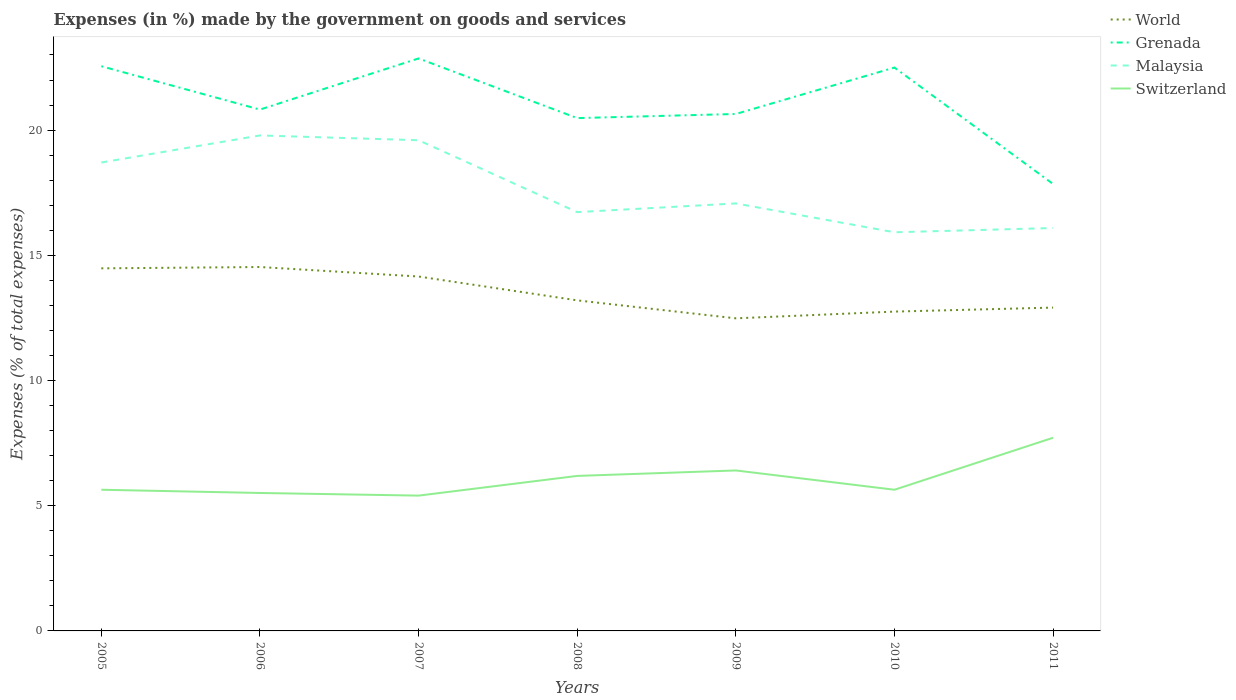Across all years, what is the maximum percentage of expenses made by the government on goods and services in Grenada?
Offer a terse response. 17.85. In which year was the percentage of expenses made by the government on goods and services in World maximum?
Make the answer very short. 2009. What is the total percentage of expenses made by the government on goods and services in Grenada in the graph?
Make the answer very short. 2.22. What is the difference between the highest and the second highest percentage of expenses made by the government on goods and services in Grenada?
Offer a very short reply. 5.01. How many years are there in the graph?
Your response must be concise. 7. What is the difference between two consecutive major ticks on the Y-axis?
Ensure brevity in your answer.  5. Does the graph contain any zero values?
Make the answer very short. No. Does the graph contain grids?
Make the answer very short. No. Where does the legend appear in the graph?
Give a very brief answer. Top right. How are the legend labels stacked?
Offer a terse response. Vertical. What is the title of the graph?
Provide a succinct answer. Expenses (in %) made by the government on goods and services. What is the label or title of the Y-axis?
Make the answer very short. Expenses (% of total expenses). What is the Expenses (% of total expenses) of World in 2005?
Provide a short and direct response. 14.48. What is the Expenses (% of total expenses) in Grenada in 2005?
Your response must be concise. 22.55. What is the Expenses (% of total expenses) in Malaysia in 2005?
Offer a very short reply. 18.71. What is the Expenses (% of total expenses) of Switzerland in 2005?
Give a very brief answer. 5.64. What is the Expenses (% of total expenses) of World in 2006?
Your answer should be very brief. 14.53. What is the Expenses (% of total expenses) in Grenada in 2006?
Provide a short and direct response. 20.82. What is the Expenses (% of total expenses) in Malaysia in 2006?
Provide a succinct answer. 19.79. What is the Expenses (% of total expenses) in Switzerland in 2006?
Provide a succinct answer. 5.51. What is the Expenses (% of total expenses) of World in 2007?
Offer a terse response. 14.15. What is the Expenses (% of total expenses) in Grenada in 2007?
Your answer should be compact. 22.86. What is the Expenses (% of total expenses) in Malaysia in 2007?
Your response must be concise. 19.6. What is the Expenses (% of total expenses) in Switzerland in 2007?
Offer a very short reply. 5.4. What is the Expenses (% of total expenses) in World in 2008?
Make the answer very short. 13.2. What is the Expenses (% of total expenses) of Grenada in 2008?
Provide a short and direct response. 20.48. What is the Expenses (% of total expenses) in Malaysia in 2008?
Your answer should be very brief. 16.72. What is the Expenses (% of total expenses) in Switzerland in 2008?
Make the answer very short. 6.19. What is the Expenses (% of total expenses) of World in 2009?
Ensure brevity in your answer.  12.48. What is the Expenses (% of total expenses) in Grenada in 2009?
Provide a succinct answer. 20.64. What is the Expenses (% of total expenses) in Malaysia in 2009?
Ensure brevity in your answer.  17.07. What is the Expenses (% of total expenses) of Switzerland in 2009?
Give a very brief answer. 6.41. What is the Expenses (% of total expenses) of World in 2010?
Offer a terse response. 12.75. What is the Expenses (% of total expenses) in Grenada in 2010?
Offer a very short reply. 22.5. What is the Expenses (% of total expenses) of Malaysia in 2010?
Keep it short and to the point. 15.92. What is the Expenses (% of total expenses) of Switzerland in 2010?
Give a very brief answer. 5.64. What is the Expenses (% of total expenses) of World in 2011?
Your answer should be very brief. 12.91. What is the Expenses (% of total expenses) in Grenada in 2011?
Your answer should be very brief. 17.85. What is the Expenses (% of total expenses) in Malaysia in 2011?
Ensure brevity in your answer.  16.09. What is the Expenses (% of total expenses) of Switzerland in 2011?
Give a very brief answer. 7.71. Across all years, what is the maximum Expenses (% of total expenses) of World?
Keep it short and to the point. 14.53. Across all years, what is the maximum Expenses (% of total expenses) of Grenada?
Provide a succinct answer. 22.86. Across all years, what is the maximum Expenses (% of total expenses) of Malaysia?
Offer a very short reply. 19.79. Across all years, what is the maximum Expenses (% of total expenses) of Switzerland?
Provide a succinct answer. 7.71. Across all years, what is the minimum Expenses (% of total expenses) in World?
Make the answer very short. 12.48. Across all years, what is the minimum Expenses (% of total expenses) of Grenada?
Give a very brief answer. 17.85. Across all years, what is the minimum Expenses (% of total expenses) of Malaysia?
Keep it short and to the point. 15.92. Across all years, what is the minimum Expenses (% of total expenses) of Switzerland?
Offer a terse response. 5.4. What is the total Expenses (% of total expenses) of World in the graph?
Offer a terse response. 94.51. What is the total Expenses (% of total expenses) of Grenada in the graph?
Provide a succinct answer. 147.7. What is the total Expenses (% of total expenses) of Malaysia in the graph?
Your response must be concise. 123.89. What is the total Expenses (% of total expenses) of Switzerland in the graph?
Make the answer very short. 42.5. What is the difference between the Expenses (% of total expenses) in World in 2005 and that in 2006?
Provide a succinct answer. -0.05. What is the difference between the Expenses (% of total expenses) of Grenada in 2005 and that in 2006?
Ensure brevity in your answer.  1.73. What is the difference between the Expenses (% of total expenses) of Malaysia in 2005 and that in 2006?
Make the answer very short. -1.08. What is the difference between the Expenses (% of total expenses) in Switzerland in 2005 and that in 2006?
Your answer should be very brief. 0.13. What is the difference between the Expenses (% of total expenses) of World in 2005 and that in 2007?
Offer a terse response. 0.33. What is the difference between the Expenses (% of total expenses) of Grenada in 2005 and that in 2007?
Give a very brief answer. -0.31. What is the difference between the Expenses (% of total expenses) in Malaysia in 2005 and that in 2007?
Provide a succinct answer. -0.89. What is the difference between the Expenses (% of total expenses) in Switzerland in 2005 and that in 2007?
Give a very brief answer. 0.23. What is the difference between the Expenses (% of total expenses) of World in 2005 and that in 2008?
Keep it short and to the point. 1.28. What is the difference between the Expenses (% of total expenses) in Grenada in 2005 and that in 2008?
Offer a very short reply. 2.07. What is the difference between the Expenses (% of total expenses) in Malaysia in 2005 and that in 2008?
Ensure brevity in your answer.  1.98. What is the difference between the Expenses (% of total expenses) of Switzerland in 2005 and that in 2008?
Provide a succinct answer. -0.55. What is the difference between the Expenses (% of total expenses) of World in 2005 and that in 2009?
Your answer should be compact. 2. What is the difference between the Expenses (% of total expenses) in Grenada in 2005 and that in 2009?
Provide a short and direct response. 1.91. What is the difference between the Expenses (% of total expenses) of Malaysia in 2005 and that in 2009?
Provide a short and direct response. 1.63. What is the difference between the Expenses (% of total expenses) of Switzerland in 2005 and that in 2009?
Keep it short and to the point. -0.77. What is the difference between the Expenses (% of total expenses) of World in 2005 and that in 2010?
Provide a short and direct response. 1.73. What is the difference between the Expenses (% of total expenses) of Grenada in 2005 and that in 2010?
Make the answer very short. 0.05. What is the difference between the Expenses (% of total expenses) in Malaysia in 2005 and that in 2010?
Ensure brevity in your answer.  2.79. What is the difference between the Expenses (% of total expenses) of Switzerland in 2005 and that in 2010?
Your answer should be compact. -0. What is the difference between the Expenses (% of total expenses) of World in 2005 and that in 2011?
Provide a short and direct response. 1.57. What is the difference between the Expenses (% of total expenses) of Grenada in 2005 and that in 2011?
Provide a succinct answer. 4.7. What is the difference between the Expenses (% of total expenses) of Malaysia in 2005 and that in 2011?
Provide a short and direct response. 2.62. What is the difference between the Expenses (% of total expenses) in Switzerland in 2005 and that in 2011?
Your response must be concise. -2.08. What is the difference between the Expenses (% of total expenses) of World in 2006 and that in 2007?
Your response must be concise. 0.38. What is the difference between the Expenses (% of total expenses) of Grenada in 2006 and that in 2007?
Your answer should be compact. -2.04. What is the difference between the Expenses (% of total expenses) of Malaysia in 2006 and that in 2007?
Your answer should be very brief. 0.19. What is the difference between the Expenses (% of total expenses) in Switzerland in 2006 and that in 2007?
Make the answer very short. 0.11. What is the difference between the Expenses (% of total expenses) in World in 2006 and that in 2008?
Offer a very short reply. 1.33. What is the difference between the Expenses (% of total expenses) of Grenada in 2006 and that in 2008?
Make the answer very short. 0.34. What is the difference between the Expenses (% of total expenses) in Malaysia in 2006 and that in 2008?
Provide a short and direct response. 3.06. What is the difference between the Expenses (% of total expenses) of Switzerland in 2006 and that in 2008?
Provide a succinct answer. -0.68. What is the difference between the Expenses (% of total expenses) of World in 2006 and that in 2009?
Make the answer very short. 2.05. What is the difference between the Expenses (% of total expenses) of Grenada in 2006 and that in 2009?
Your answer should be very brief. 0.18. What is the difference between the Expenses (% of total expenses) of Malaysia in 2006 and that in 2009?
Keep it short and to the point. 2.72. What is the difference between the Expenses (% of total expenses) in Switzerland in 2006 and that in 2009?
Your response must be concise. -0.9. What is the difference between the Expenses (% of total expenses) in World in 2006 and that in 2010?
Give a very brief answer. 1.78. What is the difference between the Expenses (% of total expenses) in Grenada in 2006 and that in 2010?
Your answer should be very brief. -1.68. What is the difference between the Expenses (% of total expenses) in Malaysia in 2006 and that in 2010?
Ensure brevity in your answer.  3.87. What is the difference between the Expenses (% of total expenses) in Switzerland in 2006 and that in 2010?
Provide a succinct answer. -0.13. What is the difference between the Expenses (% of total expenses) in World in 2006 and that in 2011?
Provide a short and direct response. 1.62. What is the difference between the Expenses (% of total expenses) of Grenada in 2006 and that in 2011?
Give a very brief answer. 2.97. What is the difference between the Expenses (% of total expenses) of Malaysia in 2006 and that in 2011?
Offer a very short reply. 3.7. What is the difference between the Expenses (% of total expenses) of Switzerland in 2006 and that in 2011?
Give a very brief answer. -2.2. What is the difference between the Expenses (% of total expenses) in World in 2007 and that in 2008?
Your answer should be compact. 0.95. What is the difference between the Expenses (% of total expenses) in Grenada in 2007 and that in 2008?
Offer a very short reply. 2.38. What is the difference between the Expenses (% of total expenses) in Malaysia in 2007 and that in 2008?
Provide a succinct answer. 2.87. What is the difference between the Expenses (% of total expenses) in Switzerland in 2007 and that in 2008?
Your answer should be compact. -0.79. What is the difference between the Expenses (% of total expenses) in World in 2007 and that in 2009?
Ensure brevity in your answer.  1.67. What is the difference between the Expenses (% of total expenses) in Grenada in 2007 and that in 2009?
Provide a short and direct response. 2.22. What is the difference between the Expenses (% of total expenses) of Malaysia in 2007 and that in 2009?
Offer a terse response. 2.52. What is the difference between the Expenses (% of total expenses) in Switzerland in 2007 and that in 2009?
Keep it short and to the point. -1. What is the difference between the Expenses (% of total expenses) in World in 2007 and that in 2010?
Your answer should be very brief. 1.4. What is the difference between the Expenses (% of total expenses) in Grenada in 2007 and that in 2010?
Your response must be concise. 0.36. What is the difference between the Expenses (% of total expenses) of Malaysia in 2007 and that in 2010?
Make the answer very short. 3.68. What is the difference between the Expenses (% of total expenses) in Switzerland in 2007 and that in 2010?
Offer a very short reply. -0.23. What is the difference between the Expenses (% of total expenses) of World in 2007 and that in 2011?
Your answer should be compact. 1.24. What is the difference between the Expenses (% of total expenses) in Grenada in 2007 and that in 2011?
Keep it short and to the point. 5.01. What is the difference between the Expenses (% of total expenses) in Malaysia in 2007 and that in 2011?
Keep it short and to the point. 3.51. What is the difference between the Expenses (% of total expenses) in Switzerland in 2007 and that in 2011?
Your answer should be compact. -2.31. What is the difference between the Expenses (% of total expenses) of World in 2008 and that in 2009?
Ensure brevity in your answer.  0.72. What is the difference between the Expenses (% of total expenses) of Grenada in 2008 and that in 2009?
Your answer should be very brief. -0.16. What is the difference between the Expenses (% of total expenses) of Malaysia in 2008 and that in 2009?
Give a very brief answer. -0.35. What is the difference between the Expenses (% of total expenses) in Switzerland in 2008 and that in 2009?
Offer a very short reply. -0.22. What is the difference between the Expenses (% of total expenses) of World in 2008 and that in 2010?
Your answer should be very brief. 0.45. What is the difference between the Expenses (% of total expenses) in Grenada in 2008 and that in 2010?
Ensure brevity in your answer.  -2.02. What is the difference between the Expenses (% of total expenses) in Malaysia in 2008 and that in 2010?
Your answer should be compact. 0.8. What is the difference between the Expenses (% of total expenses) of Switzerland in 2008 and that in 2010?
Provide a succinct answer. 0.55. What is the difference between the Expenses (% of total expenses) of World in 2008 and that in 2011?
Make the answer very short. 0.29. What is the difference between the Expenses (% of total expenses) in Grenada in 2008 and that in 2011?
Ensure brevity in your answer.  2.63. What is the difference between the Expenses (% of total expenses) of Malaysia in 2008 and that in 2011?
Make the answer very short. 0.63. What is the difference between the Expenses (% of total expenses) in Switzerland in 2008 and that in 2011?
Keep it short and to the point. -1.52. What is the difference between the Expenses (% of total expenses) in World in 2009 and that in 2010?
Offer a very short reply. -0.27. What is the difference between the Expenses (% of total expenses) in Grenada in 2009 and that in 2010?
Make the answer very short. -1.85. What is the difference between the Expenses (% of total expenses) of Malaysia in 2009 and that in 2010?
Make the answer very short. 1.15. What is the difference between the Expenses (% of total expenses) in Switzerland in 2009 and that in 2010?
Keep it short and to the point. 0.77. What is the difference between the Expenses (% of total expenses) in World in 2009 and that in 2011?
Keep it short and to the point. -0.43. What is the difference between the Expenses (% of total expenses) in Grenada in 2009 and that in 2011?
Keep it short and to the point. 2.8. What is the difference between the Expenses (% of total expenses) of Malaysia in 2009 and that in 2011?
Provide a short and direct response. 0.98. What is the difference between the Expenses (% of total expenses) in Switzerland in 2009 and that in 2011?
Your response must be concise. -1.31. What is the difference between the Expenses (% of total expenses) of World in 2010 and that in 2011?
Ensure brevity in your answer.  -0.16. What is the difference between the Expenses (% of total expenses) in Grenada in 2010 and that in 2011?
Your answer should be very brief. 4.65. What is the difference between the Expenses (% of total expenses) of Malaysia in 2010 and that in 2011?
Give a very brief answer. -0.17. What is the difference between the Expenses (% of total expenses) in Switzerland in 2010 and that in 2011?
Provide a short and direct response. -2.08. What is the difference between the Expenses (% of total expenses) in World in 2005 and the Expenses (% of total expenses) in Grenada in 2006?
Ensure brevity in your answer.  -6.34. What is the difference between the Expenses (% of total expenses) in World in 2005 and the Expenses (% of total expenses) in Malaysia in 2006?
Provide a short and direct response. -5.31. What is the difference between the Expenses (% of total expenses) of World in 2005 and the Expenses (% of total expenses) of Switzerland in 2006?
Keep it short and to the point. 8.97. What is the difference between the Expenses (% of total expenses) in Grenada in 2005 and the Expenses (% of total expenses) in Malaysia in 2006?
Give a very brief answer. 2.76. What is the difference between the Expenses (% of total expenses) in Grenada in 2005 and the Expenses (% of total expenses) in Switzerland in 2006?
Keep it short and to the point. 17.04. What is the difference between the Expenses (% of total expenses) of Malaysia in 2005 and the Expenses (% of total expenses) of Switzerland in 2006?
Offer a terse response. 13.2. What is the difference between the Expenses (% of total expenses) of World in 2005 and the Expenses (% of total expenses) of Grenada in 2007?
Ensure brevity in your answer.  -8.38. What is the difference between the Expenses (% of total expenses) in World in 2005 and the Expenses (% of total expenses) in Malaysia in 2007?
Your response must be concise. -5.12. What is the difference between the Expenses (% of total expenses) in World in 2005 and the Expenses (% of total expenses) in Switzerland in 2007?
Make the answer very short. 9.08. What is the difference between the Expenses (% of total expenses) in Grenada in 2005 and the Expenses (% of total expenses) in Malaysia in 2007?
Give a very brief answer. 2.96. What is the difference between the Expenses (% of total expenses) of Grenada in 2005 and the Expenses (% of total expenses) of Switzerland in 2007?
Give a very brief answer. 17.15. What is the difference between the Expenses (% of total expenses) in Malaysia in 2005 and the Expenses (% of total expenses) in Switzerland in 2007?
Offer a terse response. 13.3. What is the difference between the Expenses (% of total expenses) in World in 2005 and the Expenses (% of total expenses) in Malaysia in 2008?
Provide a succinct answer. -2.25. What is the difference between the Expenses (% of total expenses) in World in 2005 and the Expenses (% of total expenses) in Switzerland in 2008?
Your answer should be very brief. 8.29. What is the difference between the Expenses (% of total expenses) in Grenada in 2005 and the Expenses (% of total expenses) in Malaysia in 2008?
Your response must be concise. 5.83. What is the difference between the Expenses (% of total expenses) in Grenada in 2005 and the Expenses (% of total expenses) in Switzerland in 2008?
Give a very brief answer. 16.36. What is the difference between the Expenses (% of total expenses) in Malaysia in 2005 and the Expenses (% of total expenses) in Switzerland in 2008?
Provide a succinct answer. 12.52. What is the difference between the Expenses (% of total expenses) in World in 2005 and the Expenses (% of total expenses) in Grenada in 2009?
Provide a succinct answer. -6.16. What is the difference between the Expenses (% of total expenses) in World in 2005 and the Expenses (% of total expenses) in Malaysia in 2009?
Your answer should be compact. -2.59. What is the difference between the Expenses (% of total expenses) in World in 2005 and the Expenses (% of total expenses) in Switzerland in 2009?
Offer a very short reply. 8.07. What is the difference between the Expenses (% of total expenses) of Grenada in 2005 and the Expenses (% of total expenses) of Malaysia in 2009?
Keep it short and to the point. 5.48. What is the difference between the Expenses (% of total expenses) in Grenada in 2005 and the Expenses (% of total expenses) in Switzerland in 2009?
Make the answer very short. 16.14. What is the difference between the Expenses (% of total expenses) of Malaysia in 2005 and the Expenses (% of total expenses) of Switzerland in 2009?
Your answer should be very brief. 12.3. What is the difference between the Expenses (% of total expenses) of World in 2005 and the Expenses (% of total expenses) of Grenada in 2010?
Make the answer very short. -8.02. What is the difference between the Expenses (% of total expenses) of World in 2005 and the Expenses (% of total expenses) of Malaysia in 2010?
Provide a succinct answer. -1.44. What is the difference between the Expenses (% of total expenses) of World in 2005 and the Expenses (% of total expenses) of Switzerland in 2010?
Ensure brevity in your answer.  8.84. What is the difference between the Expenses (% of total expenses) in Grenada in 2005 and the Expenses (% of total expenses) in Malaysia in 2010?
Your response must be concise. 6.63. What is the difference between the Expenses (% of total expenses) in Grenada in 2005 and the Expenses (% of total expenses) in Switzerland in 2010?
Offer a terse response. 16.91. What is the difference between the Expenses (% of total expenses) in Malaysia in 2005 and the Expenses (% of total expenses) in Switzerland in 2010?
Your response must be concise. 13.07. What is the difference between the Expenses (% of total expenses) of World in 2005 and the Expenses (% of total expenses) of Grenada in 2011?
Your answer should be compact. -3.37. What is the difference between the Expenses (% of total expenses) in World in 2005 and the Expenses (% of total expenses) in Malaysia in 2011?
Provide a succinct answer. -1.61. What is the difference between the Expenses (% of total expenses) in World in 2005 and the Expenses (% of total expenses) in Switzerland in 2011?
Your answer should be very brief. 6.76. What is the difference between the Expenses (% of total expenses) in Grenada in 2005 and the Expenses (% of total expenses) in Malaysia in 2011?
Offer a terse response. 6.46. What is the difference between the Expenses (% of total expenses) of Grenada in 2005 and the Expenses (% of total expenses) of Switzerland in 2011?
Your response must be concise. 14.84. What is the difference between the Expenses (% of total expenses) in Malaysia in 2005 and the Expenses (% of total expenses) in Switzerland in 2011?
Provide a short and direct response. 10.99. What is the difference between the Expenses (% of total expenses) of World in 2006 and the Expenses (% of total expenses) of Grenada in 2007?
Make the answer very short. -8.33. What is the difference between the Expenses (% of total expenses) of World in 2006 and the Expenses (% of total expenses) of Malaysia in 2007?
Your answer should be very brief. -5.06. What is the difference between the Expenses (% of total expenses) in World in 2006 and the Expenses (% of total expenses) in Switzerland in 2007?
Provide a short and direct response. 9.13. What is the difference between the Expenses (% of total expenses) in Grenada in 2006 and the Expenses (% of total expenses) in Malaysia in 2007?
Provide a short and direct response. 1.22. What is the difference between the Expenses (% of total expenses) in Grenada in 2006 and the Expenses (% of total expenses) in Switzerland in 2007?
Provide a short and direct response. 15.42. What is the difference between the Expenses (% of total expenses) in Malaysia in 2006 and the Expenses (% of total expenses) in Switzerland in 2007?
Provide a succinct answer. 14.38. What is the difference between the Expenses (% of total expenses) of World in 2006 and the Expenses (% of total expenses) of Grenada in 2008?
Ensure brevity in your answer.  -5.95. What is the difference between the Expenses (% of total expenses) of World in 2006 and the Expenses (% of total expenses) of Malaysia in 2008?
Make the answer very short. -2.19. What is the difference between the Expenses (% of total expenses) in World in 2006 and the Expenses (% of total expenses) in Switzerland in 2008?
Offer a very short reply. 8.34. What is the difference between the Expenses (% of total expenses) in Grenada in 2006 and the Expenses (% of total expenses) in Malaysia in 2008?
Give a very brief answer. 4.09. What is the difference between the Expenses (% of total expenses) of Grenada in 2006 and the Expenses (% of total expenses) of Switzerland in 2008?
Give a very brief answer. 14.63. What is the difference between the Expenses (% of total expenses) of Malaysia in 2006 and the Expenses (% of total expenses) of Switzerland in 2008?
Offer a terse response. 13.6. What is the difference between the Expenses (% of total expenses) in World in 2006 and the Expenses (% of total expenses) in Grenada in 2009?
Give a very brief answer. -6.11. What is the difference between the Expenses (% of total expenses) in World in 2006 and the Expenses (% of total expenses) in Malaysia in 2009?
Offer a very short reply. -2.54. What is the difference between the Expenses (% of total expenses) of World in 2006 and the Expenses (% of total expenses) of Switzerland in 2009?
Ensure brevity in your answer.  8.12. What is the difference between the Expenses (% of total expenses) of Grenada in 2006 and the Expenses (% of total expenses) of Malaysia in 2009?
Give a very brief answer. 3.75. What is the difference between the Expenses (% of total expenses) of Grenada in 2006 and the Expenses (% of total expenses) of Switzerland in 2009?
Offer a terse response. 14.41. What is the difference between the Expenses (% of total expenses) of Malaysia in 2006 and the Expenses (% of total expenses) of Switzerland in 2009?
Provide a succinct answer. 13.38. What is the difference between the Expenses (% of total expenses) of World in 2006 and the Expenses (% of total expenses) of Grenada in 2010?
Your response must be concise. -7.96. What is the difference between the Expenses (% of total expenses) in World in 2006 and the Expenses (% of total expenses) in Malaysia in 2010?
Ensure brevity in your answer.  -1.39. What is the difference between the Expenses (% of total expenses) in World in 2006 and the Expenses (% of total expenses) in Switzerland in 2010?
Provide a succinct answer. 8.89. What is the difference between the Expenses (% of total expenses) in Grenada in 2006 and the Expenses (% of total expenses) in Malaysia in 2010?
Provide a succinct answer. 4.9. What is the difference between the Expenses (% of total expenses) in Grenada in 2006 and the Expenses (% of total expenses) in Switzerland in 2010?
Offer a very short reply. 15.18. What is the difference between the Expenses (% of total expenses) of Malaysia in 2006 and the Expenses (% of total expenses) of Switzerland in 2010?
Your answer should be compact. 14.15. What is the difference between the Expenses (% of total expenses) of World in 2006 and the Expenses (% of total expenses) of Grenada in 2011?
Make the answer very short. -3.32. What is the difference between the Expenses (% of total expenses) of World in 2006 and the Expenses (% of total expenses) of Malaysia in 2011?
Give a very brief answer. -1.56. What is the difference between the Expenses (% of total expenses) of World in 2006 and the Expenses (% of total expenses) of Switzerland in 2011?
Provide a short and direct response. 6.82. What is the difference between the Expenses (% of total expenses) of Grenada in 2006 and the Expenses (% of total expenses) of Malaysia in 2011?
Offer a terse response. 4.73. What is the difference between the Expenses (% of total expenses) of Grenada in 2006 and the Expenses (% of total expenses) of Switzerland in 2011?
Offer a terse response. 13.11. What is the difference between the Expenses (% of total expenses) of Malaysia in 2006 and the Expenses (% of total expenses) of Switzerland in 2011?
Your answer should be compact. 12.07. What is the difference between the Expenses (% of total expenses) of World in 2007 and the Expenses (% of total expenses) of Grenada in 2008?
Give a very brief answer. -6.33. What is the difference between the Expenses (% of total expenses) in World in 2007 and the Expenses (% of total expenses) in Malaysia in 2008?
Your answer should be compact. -2.57. What is the difference between the Expenses (% of total expenses) of World in 2007 and the Expenses (% of total expenses) of Switzerland in 2008?
Your answer should be compact. 7.96. What is the difference between the Expenses (% of total expenses) of Grenada in 2007 and the Expenses (% of total expenses) of Malaysia in 2008?
Ensure brevity in your answer.  6.14. What is the difference between the Expenses (% of total expenses) of Grenada in 2007 and the Expenses (% of total expenses) of Switzerland in 2008?
Ensure brevity in your answer.  16.67. What is the difference between the Expenses (% of total expenses) in Malaysia in 2007 and the Expenses (% of total expenses) in Switzerland in 2008?
Provide a succinct answer. 13.41. What is the difference between the Expenses (% of total expenses) of World in 2007 and the Expenses (% of total expenses) of Grenada in 2009?
Your answer should be very brief. -6.49. What is the difference between the Expenses (% of total expenses) in World in 2007 and the Expenses (% of total expenses) in Malaysia in 2009?
Give a very brief answer. -2.92. What is the difference between the Expenses (% of total expenses) of World in 2007 and the Expenses (% of total expenses) of Switzerland in 2009?
Ensure brevity in your answer.  7.74. What is the difference between the Expenses (% of total expenses) of Grenada in 2007 and the Expenses (% of total expenses) of Malaysia in 2009?
Your answer should be compact. 5.79. What is the difference between the Expenses (% of total expenses) of Grenada in 2007 and the Expenses (% of total expenses) of Switzerland in 2009?
Your answer should be very brief. 16.45. What is the difference between the Expenses (% of total expenses) in Malaysia in 2007 and the Expenses (% of total expenses) in Switzerland in 2009?
Keep it short and to the point. 13.19. What is the difference between the Expenses (% of total expenses) of World in 2007 and the Expenses (% of total expenses) of Grenada in 2010?
Your response must be concise. -8.34. What is the difference between the Expenses (% of total expenses) of World in 2007 and the Expenses (% of total expenses) of Malaysia in 2010?
Provide a short and direct response. -1.77. What is the difference between the Expenses (% of total expenses) in World in 2007 and the Expenses (% of total expenses) in Switzerland in 2010?
Provide a succinct answer. 8.51. What is the difference between the Expenses (% of total expenses) of Grenada in 2007 and the Expenses (% of total expenses) of Malaysia in 2010?
Ensure brevity in your answer.  6.94. What is the difference between the Expenses (% of total expenses) in Grenada in 2007 and the Expenses (% of total expenses) in Switzerland in 2010?
Make the answer very short. 17.22. What is the difference between the Expenses (% of total expenses) of Malaysia in 2007 and the Expenses (% of total expenses) of Switzerland in 2010?
Your response must be concise. 13.96. What is the difference between the Expenses (% of total expenses) in World in 2007 and the Expenses (% of total expenses) in Grenada in 2011?
Offer a terse response. -3.69. What is the difference between the Expenses (% of total expenses) of World in 2007 and the Expenses (% of total expenses) of Malaysia in 2011?
Ensure brevity in your answer.  -1.94. What is the difference between the Expenses (% of total expenses) of World in 2007 and the Expenses (% of total expenses) of Switzerland in 2011?
Provide a succinct answer. 6.44. What is the difference between the Expenses (% of total expenses) in Grenada in 2007 and the Expenses (% of total expenses) in Malaysia in 2011?
Your answer should be very brief. 6.77. What is the difference between the Expenses (% of total expenses) of Grenada in 2007 and the Expenses (% of total expenses) of Switzerland in 2011?
Ensure brevity in your answer.  15.15. What is the difference between the Expenses (% of total expenses) of Malaysia in 2007 and the Expenses (% of total expenses) of Switzerland in 2011?
Provide a succinct answer. 11.88. What is the difference between the Expenses (% of total expenses) in World in 2008 and the Expenses (% of total expenses) in Grenada in 2009?
Ensure brevity in your answer.  -7.44. What is the difference between the Expenses (% of total expenses) in World in 2008 and the Expenses (% of total expenses) in Malaysia in 2009?
Ensure brevity in your answer.  -3.87. What is the difference between the Expenses (% of total expenses) in World in 2008 and the Expenses (% of total expenses) in Switzerland in 2009?
Offer a very short reply. 6.79. What is the difference between the Expenses (% of total expenses) in Grenada in 2008 and the Expenses (% of total expenses) in Malaysia in 2009?
Provide a succinct answer. 3.41. What is the difference between the Expenses (% of total expenses) of Grenada in 2008 and the Expenses (% of total expenses) of Switzerland in 2009?
Offer a terse response. 14.07. What is the difference between the Expenses (% of total expenses) in Malaysia in 2008 and the Expenses (% of total expenses) in Switzerland in 2009?
Offer a very short reply. 10.32. What is the difference between the Expenses (% of total expenses) of World in 2008 and the Expenses (% of total expenses) of Grenada in 2010?
Ensure brevity in your answer.  -9.3. What is the difference between the Expenses (% of total expenses) of World in 2008 and the Expenses (% of total expenses) of Malaysia in 2010?
Keep it short and to the point. -2.72. What is the difference between the Expenses (% of total expenses) of World in 2008 and the Expenses (% of total expenses) of Switzerland in 2010?
Provide a short and direct response. 7.56. What is the difference between the Expenses (% of total expenses) in Grenada in 2008 and the Expenses (% of total expenses) in Malaysia in 2010?
Offer a terse response. 4.56. What is the difference between the Expenses (% of total expenses) of Grenada in 2008 and the Expenses (% of total expenses) of Switzerland in 2010?
Provide a short and direct response. 14.84. What is the difference between the Expenses (% of total expenses) of Malaysia in 2008 and the Expenses (% of total expenses) of Switzerland in 2010?
Provide a short and direct response. 11.09. What is the difference between the Expenses (% of total expenses) of World in 2008 and the Expenses (% of total expenses) of Grenada in 2011?
Provide a short and direct response. -4.65. What is the difference between the Expenses (% of total expenses) of World in 2008 and the Expenses (% of total expenses) of Malaysia in 2011?
Keep it short and to the point. -2.89. What is the difference between the Expenses (% of total expenses) in World in 2008 and the Expenses (% of total expenses) in Switzerland in 2011?
Give a very brief answer. 5.49. What is the difference between the Expenses (% of total expenses) of Grenada in 2008 and the Expenses (% of total expenses) of Malaysia in 2011?
Ensure brevity in your answer.  4.39. What is the difference between the Expenses (% of total expenses) of Grenada in 2008 and the Expenses (% of total expenses) of Switzerland in 2011?
Give a very brief answer. 12.77. What is the difference between the Expenses (% of total expenses) of Malaysia in 2008 and the Expenses (% of total expenses) of Switzerland in 2011?
Your response must be concise. 9.01. What is the difference between the Expenses (% of total expenses) of World in 2009 and the Expenses (% of total expenses) of Grenada in 2010?
Give a very brief answer. -10.01. What is the difference between the Expenses (% of total expenses) in World in 2009 and the Expenses (% of total expenses) in Malaysia in 2010?
Ensure brevity in your answer.  -3.44. What is the difference between the Expenses (% of total expenses) in World in 2009 and the Expenses (% of total expenses) in Switzerland in 2010?
Offer a terse response. 6.84. What is the difference between the Expenses (% of total expenses) in Grenada in 2009 and the Expenses (% of total expenses) in Malaysia in 2010?
Provide a succinct answer. 4.72. What is the difference between the Expenses (% of total expenses) in Grenada in 2009 and the Expenses (% of total expenses) in Switzerland in 2010?
Offer a terse response. 15.01. What is the difference between the Expenses (% of total expenses) in Malaysia in 2009 and the Expenses (% of total expenses) in Switzerland in 2010?
Offer a very short reply. 11.43. What is the difference between the Expenses (% of total expenses) in World in 2009 and the Expenses (% of total expenses) in Grenada in 2011?
Your answer should be very brief. -5.36. What is the difference between the Expenses (% of total expenses) of World in 2009 and the Expenses (% of total expenses) of Malaysia in 2011?
Offer a terse response. -3.61. What is the difference between the Expenses (% of total expenses) of World in 2009 and the Expenses (% of total expenses) of Switzerland in 2011?
Your answer should be very brief. 4.77. What is the difference between the Expenses (% of total expenses) in Grenada in 2009 and the Expenses (% of total expenses) in Malaysia in 2011?
Provide a succinct answer. 4.55. What is the difference between the Expenses (% of total expenses) of Grenada in 2009 and the Expenses (% of total expenses) of Switzerland in 2011?
Give a very brief answer. 12.93. What is the difference between the Expenses (% of total expenses) of Malaysia in 2009 and the Expenses (% of total expenses) of Switzerland in 2011?
Your response must be concise. 9.36. What is the difference between the Expenses (% of total expenses) of World in 2010 and the Expenses (% of total expenses) of Grenada in 2011?
Your response must be concise. -5.1. What is the difference between the Expenses (% of total expenses) of World in 2010 and the Expenses (% of total expenses) of Malaysia in 2011?
Your answer should be compact. -3.34. What is the difference between the Expenses (% of total expenses) in World in 2010 and the Expenses (% of total expenses) in Switzerland in 2011?
Provide a succinct answer. 5.04. What is the difference between the Expenses (% of total expenses) in Grenada in 2010 and the Expenses (% of total expenses) in Malaysia in 2011?
Your answer should be very brief. 6.41. What is the difference between the Expenses (% of total expenses) of Grenada in 2010 and the Expenses (% of total expenses) of Switzerland in 2011?
Offer a terse response. 14.78. What is the difference between the Expenses (% of total expenses) of Malaysia in 2010 and the Expenses (% of total expenses) of Switzerland in 2011?
Ensure brevity in your answer.  8.21. What is the average Expenses (% of total expenses) of World per year?
Keep it short and to the point. 13.5. What is the average Expenses (% of total expenses) of Grenada per year?
Your response must be concise. 21.1. What is the average Expenses (% of total expenses) in Malaysia per year?
Offer a very short reply. 17.7. What is the average Expenses (% of total expenses) of Switzerland per year?
Provide a succinct answer. 6.07. In the year 2005, what is the difference between the Expenses (% of total expenses) of World and Expenses (% of total expenses) of Grenada?
Provide a short and direct response. -8.07. In the year 2005, what is the difference between the Expenses (% of total expenses) of World and Expenses (% of total expenses) of Malaysia?
Your answer should be very brief. -4.23. In the year 2005, what is the difference between the Expenses (% of total expenses) of World and Expenses (% of total expenses) of Switzerland?
Keep it short and to the point. 8.84. In the year 2005, what is the difference between the Expenses (% of total expenses) in Grenada and Expenses (% of total expenses) in Malaysia?
Your answer should be compact. 3.84. In the year 2005, what is the difference between the Expenses (% of total expenses) of Grenada and Expenses (% of total expenses) of Switzerland?
Your answer should be very brief. 16.91. In the year 2005, what is the difference between the Expenses (% of total expenses) of Malaysia and Expenses (% of total expenses) of Switzerland?
Provide a short and direct response. 13.07. In the year 2006, what is the difference between the Expenses (% of total expenses) in World and Expenses (% of total expenses) in Grenada?
Provide a short and direct response. -6.29. In the year 2006, what is the difference between the Expenses (% of total expenses) of World and Expenses (% of total expenses) of Malaysia?
Provide a short and direct response. -5.25. In the year 2006, what is the difference between the Expenses (% of total expenses) in World and Expenses (% of total expenses) in Switzerland?
Your answer should be compact. 9.02. In the year 2006, what is the difference between the Expenses (% of total expenses) in Grenada and Expenses (% of total expenses) in Malaysia?
Provide a succinct answer. 1.03. In the year 2006, what is the difference between the Expenses (% of total expenses) of Grenada and Expenses (% of total expenses) of Switzerland?
Provide a short and direct response. 15.31. In the year 2006, what is the difference between the Expenses (% of total expenses) in Malaysia and Expenses (% of total expenses) in Switzerland?
Ensure brevity in your answer.  14.28. In the year 2007, what is the difference between the Expenses (% of total expenses) in World and Expenses (% of total expenses) in Grenada?
Offer a very short reply. -8.71. In the year 2007, what is the difference between the Expenses (% of total expenses) of World and Expenses (% of total expenses) of Malaysia?
Make the answer very short. -5.44. In the year 2007, what is the difference between the Expenses (% of total expenses) in World and Expenses (% of total expenses) in Switzerland?
Your response must be concise. 8.75. In the year 2007, what is the difference between the Expenses (% of total expenses) of Grenada and Expenses (% of total expenses) of Malaysia?
Offer a terse response. 3.27. In the year 2007, what is the difference between the Expenses (% of total expenses) in Grenada and Expenses (% of total expenses) in Switzerland?
Keep it short and to the point. 17.46. In the year 2007, what is the difference between the Expenses (% of total expenses) of Malaysia and Expenses (% of total expenses) of Switzerland?
Your answer should be very brief. 14.19. In the year 2008, what is the difference between the Expenses (% of total expenses) of World and Expenses (% of total expenses) of Grenada?
Ensure brevity in your answer.  -7.28. In the year 2008, what is the difference between the Expenses (% of total expenses) in World and Expenses (% of total expenses) in Malaysia?
Your answer should be compact. -3.52. In the year 2008, what is the difference between the Expenses (% of total expenses) of World and Expenses (% of total expenses) of Switzerland?
Your response must be concise. 7.01. In the year 2008, what is the difference between the Expenses (% of total expenses) of Grenada and Expenses (% of total expenses) of Malaysia?
Offer a very short reply. 3.75. In the year 2008, what is the difference between the Expenses (% of total expenses) in Grenada and Expenses (% of total expenses) in Switzerland?
Offer a very short reply. 14.29. In the year 2008, what is the difference between the Expenses (% of total expenses) in Malaysia and Expenses (% of total expenses) in Switzerland?
Offer a very short reply. 10.53. In the year 2009, what is the difference between the Expenses (% of total expenses) of World and Expenses (% of total expenses) of Grenada?
Provide a succinct answer. -8.16. In the year 2009, what is the difference between the Expenses (% of total expenses) of World and Expenses (% of total expenses) of Malaysia?
Give a very brief answer. -4.59. In the year 2009, what is the difference between the Expenses (% of total expenses) in World and Expenses (% of total expenses) in Switzerland?
Your response must be concise. 6.07. In the year 2009, what is the difference between the Expenses (% of total expenses) of Grenada and Expenses (% of total expenses) of Malaysia?
Make the answer very short. 3.57. In the year 2009, what is the difference between the Expenses (% of total expenses) of Grenada and Expenses (% of total expenses) of Switzerland?
Your response must be concise. 14.23. In the year 2009, what is the difference between the Expenses (% of total expenses) of Malaysia and Expenses (% of total expenses) of Switzerland?
Give a very brief answer. 10.66. In the year 2010, what is the difference between the Expenses (% of total expenses) in World and Expenses (% of total expenses) in Grenada?
Your response must be concise. -9.75. In the year 2010, what is the difference between the Expenses (% of total expenses) in World and Expenses (% of total expenses) in Malaysia?
Offer a terse response. -3.17. In the year 2010, what is the difference between the Expenses (% of total expenses) in World and Expenses (% of total expenses) in Switzerland?
Give a very brief answer. 7.11. In the year 2010, what is the difference between the Expenses (% of total expenses) in Grenada and Expenses (% of total expenses) in Malaysia?
Your answer should be very brief. 6.58. In the year 2010, what is the difference between the Expenses (% of total expenses) of Grenada and Expenses (% of total expenses) of Switzerland?
Provide a succinct answer. 16.86. In the year 2010, what is the difference between the Expenses (% of total expenses) in Malaysia and Expenses (% of total expenses) in Switzerland?
Ensure brevity in your answer.  10.28. In the year 2011, what is the difference between the Expenses (% of total expenses) in World and Expenses (% of total expenses) in Grenada?
Ensure brevity in your answer.  -4.94. In the year 2011, what is the difference between the Expenses (% of total expenses) in World and Expenses (% of total expenses) in Malaysia?
Offer a very short reply. -3.18. In the year 2011, what is the difference between the Expenses (% of total expenses) of World and Expenses (% of total expenses) of Switzerland?
Offer a terse response. 5.2. In the year 2011, what is the difference between the Expenses (% of total expenses) in Grenada and Expenses (% of total expenses) in Malaysia?
Provide a short and direct response. 1.76. In the year 2011, what is the difference between the Expenses (% of total expenses) of Grenada and Expenses (% of total expenses) of Switzerland?
Offer a terse response. 10.13. In the year 2011, what is the difference between the Expenses (% of total expenses) in Malaysia and Expenses (% of total expenses) in Switzerland?
Make the answer very short. 8.38. What is the ratio of the Expenses (% of total expenses) in Grenada in 2005 to that in 2006?
Provide a succinct answer. 1.08. What is the ratio of the Expenses (% of total expenses) of Malaysia in 2005 to that in 2006?
Make the answer very short. 0.95. What is the ratio of the Expenses (% of total expenses) in Switzerland in 2005 to that in 2006?
Ensure brevity in your answer.  1.02. What is the ratio of the Expenses (% of total expenses) of World in 2005 to that in 2007?
Ensure brevity in your answer.  1.02. What is the ratio of the Expenses (% of total expenses) of Grenada in 2005 to that in 2007?
Make the answer very short. 0.99. What is the ratio of the Expenses (% of total expenses) in Malaysia in 2005 to that in 2007?
Offer a terse response. 0.95. What is the ratio of the Expenses (% of total expenses) in Switzerland in 2005 to that in 2007?
Keep it short and to the point. 1.04. What is the ratio of the Expenses (% of total expenses) of World in 2005 to that in 2008?
Offer a very short reply. 1.1. What is the ratio of the Expenses (% of total expenses) in Grenada in 2005 to that in 2008?
Your answer should be very brief. 1.1. What is the ratio of the Expenses (% of total expenses) in Malaysia in 2005 to that in 2008?
Your answer should be very brief. 1.12. What is the ratio of the Expenses (% of total expenses) in Switzerland in 2005 to that in 2008?
Offer a very short reply. 0.91. What is the ratio of the Expenses (% of total expenses) in World in 2005 to that in 2009?
Give a very brief answer. 1.16. What is the ratio of the Expenses (% of total expenses) of Grenada in 2005 to that in 2009?
Keep it short and to the point. 1.09. What is the ratio of the Expenses (% of total expenses) in Malaysia in 2005 to that in 2009?
Provide a succinct answer. 1.1. What is the ratio of the Expenses (% of total expenses) in Switzerland in 2005 to that in 2009?
Offer a terse response. 0.88. What is the ratio of the Expenses (% of total expenses) in World in 2005 to that in 2010?
Give a very brief answer. 1.14. What is the ratio of the Expenses (% of total expenses) in Malaysia in 2005 to that in 2010?
Ensure brevity in your answer.  1.18. What is the ratio of the Expenses (% of total expenses) in World in 2005 to that in 2011?
Provide a short and direct response. 1.12. What is the ratio of the Expenses (% of total expenses) in Grenada in 2005 to that in 2011?
Provide a succinct answer. 1.26. What is the ratio of the Expenses (% of total expenses) in Malaysia in 2005 to that in 2011?
Your answer should be compact. 1.16. What is the ratio of the Expenses (% of total expenses) of Switzerland in 2005 to that in 2011?
Your answer should be very brief. 0.73. What is the ratio of the Expenses (% of total expenses) in World in 2006 to that in 2007?
Your answer should be very brief. 1.03. What is the ratio of the Expenses (% of total expenses) of Grenada in 2006 to that in 2007?
Give a very brief answer. 0.91. What is the ratio of the Expenses (% of total expenses) of Malaysia in 2006 to that in 2007?
Ensure brevity in your answer.  1.01. What is the ratio of the Expenses (% of total expenses) of Switzerland in 2006 to that in 2007?
Your answer should be compact. 1.02. What is the ratio of the Expenses (% of total expenses) in World in 2006 to that in 2008?
Provide a short and direct response. 1.1. What is the ratio of the Expenses (% of total expenses) in Grenada in 2006 to that in 2008?
Give a very brief answer. 1.02. What is the ratio of the Expenses (% of total expenses) in Malaysia in 2006 to that in 2008?
Offer a terse response. 1.18. What is the ratio of the Expenses (% of total expenses) in Switzerland in 2006 to that in 2008?
Your answer should be compact. 0.89. What is the ratio of the Expenses (% of total expenses) in World in 2006 to that in 2009?
Your response must be concise. 1.16. What is the ratio of the Expenses (% of total expenses) of Grenada in 2006 to that in 2009?
Make the answer very short. 1.01. What is the ratio of the Expenses (% of total expenses) of Malaysia in 2006 to that in 2009?
Ensure brevity in your answer.  1.16. What is the ratio of the Expenses (% of total expenses) in Switzerland in 2006 to that in 2009?
Your answer should be very brief. 0.86. What is the ratio of the Expenses (% of total expenses) of World in 2006 to that in 2010?
Provide a succinct answer. 1.14. What is the ratio of the Expenses (% of total expenses) in Grenada in 2006 to that in 2010?
Give a very brief answer. 0.93. What is the ratio of the Expenses (% of total expenses) in Malaysia in 2006 to that in 2010?
Keep it short and to the point. 1.24. What is the ratio of the Expenses (% of total expenses) in Switzerland in 2006 to that in 2010?
Offer a terse response. 0.98. What is the ratio of the Expenses (% of total expenses) in World in 2006 to that in 2011?
Your answer should be compact. 1.13. What is the ratio of the Expenses (% of total expenses) of Grenada in 2006 to that in 2011?
Provide a short and direct response. 1.17. What is the ratio of the Expenses (% of total expenses) of Malaysia in 2006 to that in 2011?
Your answer should be compact. 1.23. What is the ratio of the Expenses (% of total expenses) in Switzerland in 2006 to that in 2011?
Your answer should be compact. 0.71. What is the ratio of the Expenses (% of total expenses) in World in 2007 to that in 2008?
Your answer should be compact. 1.07. What is the ratio of the Expenses (% of total expenses) in Grenada in 2007 to that in 2008?
Provide a succinct answer. 1.12. What is the ratio of the Expenses (% of total expenses) of Malaysia in 2007 to that in 2008?
Your answer should be very brief. 1.17. What is the ratio of the Expenses (% of total expenses) of Switzerland in 2007 to that in 2008?
Provide a succinct answer. 0.87. What is the ratio of the Expenses (% of total expenses) of World in 2007 to that in 2009?
Keep it short and to the point. 1.13. What is the ratio of the Expenses (% of total expenses) in Grenada in 2007 to that in 2009?
Make the answer very short. 1.11. What is the ratio of the Expenses (% of total expenses) of Malaysia in 2007 to that in 2009?
Your answer should be very brief. 1.15. What is the ratio of the Expenses (% of total expenses) of Switzerland in 2007 to that in 2009?
Keep it short and to the point. 0.84. What is the ratio of the Expenses (% of total expenses) in World in 2007 to that in 2010?
Keep it short and to the point. 1.11. What is the ratio of the Expenses (% of total expenses) in Grenada in 2007 to that in 2010?
Offer a terse response. 1.02. What is the ratio of the Expenses (% of total expenses) of Malaysia in 2007 to that in 2010?
Make the answer very short. 1.23. What is the ratio of the Expenses (% of total expenses) in Switzerland in 2007 to that in 2010?
Make the answer very short. 0.96. What is the ratio of the Expenses (% of total expenses) in World in 2007 to that in 2011?
Ensure brevity in your answer.  1.1. What is the ratio of the Expenses (% of total expenses) of Grenada in 2007 to that in 2011?
Your response must be concise. 1.28. What is the ratio of the Expenses (% of total expenses) of Malaysia in 2007 to that in 2011?
Your response must be concise. 1.22. What is the ratio of the Expenses (% of total expenses) in Switzerland in 2007 to that in 2011?
Your answer should be compact. 0.7. What is the ratio of the Expenses (% of total expenses) in World in 2008 to that in 2009?
Your response must be concise. 1.06. What is the ratio of the Expenses (% of total expenses) of Grenada in 2008 to that in 2009?
Ensure brevity in your answer.  0.99. What is the ratio of the Expenses (% of total expenses) in Malaysia in 2008 to that in 2009?
Your answer should be very brief. 0.98. What is the ratio of the Expenses (% of total expenses) in Switzerland in 2008 to that in 2009?
Give a very brief answer. 0.97. What is the ratio of the Expenses (% of total expenses) of World in 2008 to that in 2010?
Provide a succinct answer. 1.04. What is the ratio of the Expenses (% of total expenses) of Grenada in 2008 to that in 2010?
Ensure brevity in your answer.  0.91. What is the ratio of the Expenses (% of total expenses) in Malaysia in 2008 to that in 2010?
Your answer should be compact. 1.05. What is the ratio of the Expenses (% of total expenses) of Switzerland in 2008 to that in 2010?
Ensure brevity in your answer.  1.1. What is the ratio of the Expenses (% of total expenses) of World in 2008 to that in 2011?
Offer a terse response. 1.02. What is the ratio of the Expenses (% of total expenses) in Grenada in 2008 to that in 2011?
Make the answer very short. 1.15. What is the ratio of the Expenses (% of total expenses) in Malaysia in 2008 to that in 2011?
Provide a succinct answer. 1.04. What is the ratio of the Expenses (% of total expenses) in Switzerland in 2008 to that in 2011?
Provide a succinct answer. 0.8. What is the ratio of the Expenses (% of total expenses) of World in 2009 to that in 2010?
Your answer should be compact. 0.98. What is the ratio of the Expenses (% of total expenses) in Grenada in 2009 to that in 2010?
Your answer should be compact. 0.92. What is the ratio of the Expenses (% of total expenses) in Malaysia in 2009 to that in 2010?
Your response must be concise. 1.07. What is the ratio of the Expenses (% of total expenses) in Switzerland in 2009 to that in 2010?
Keep it short and to the point. 1.14. What is the ratio of the Expenses (% of total expenses) of World in 2009 to that in 2011?
Offer a very short reply. 0.97. What is the ratio of the Expenses (% of total expenses) in Grenada in 2009 to that in 2011?
Provide a succinct answer. 1.16. What is the ratio of the Expenses (% of total expenses) in Malaysia in 2009 to that in 2011?
Offer a very short reply. 1.06. What is the ratio of the Expenses (% of total expenses) of Switzerland in 2009 to that in 2011?
Provide a succinct answer. 0.83. What is the ratio of the Expenses (% of total expenses) of World in 2010 to that in 2011?
Provide a succinct answer. 0.99. What is the ratio of the Expenses (% of total expenses) in Grenada in 2010 to that in 2011?
Make the answer very short. 1.26. What is the ratio of the Expenses (% of total expenses) in Malaysia in 2010 to that in 2011?
Your response must be concise. 0.99. What is the ratio of the Expenses (% of total expenses) of Switzerland in 2010 to that in 2011?
Your answer should be very brief. 0.73. What is the difference between the highest and the second highest Expenses (% of total expenses) in World?
Your answer should be very brief. 0.05. What is the difference between the highest and the second highest Expenses (% of total expenses) in Grenada?
Offer a terse response. 0.31. What is the difference between the highest and the second highest Expenses (% of total expenses) of Malaysia?
Your answer should be compact. 0.19. What is the difference between the highest and the second highest Expenses (% of total expenses) of Switzerland?
Offer a terse response. 1.31. What is the difference between the highest and the lowest Expenses (% of total expenses) of World?
Keep it short and to the point. 2.05. What is the difference between the highest and the lowest Expenses (% of total expenses) of Grenada?
Provide a succinct answer. 5.01. What is the difference between the highest and the lowest Expenses (% of total expenses) of Malaysia?
Your answer should be very brief. 3.87. What is the difference between the highest and the lowest Expenses (% of total expenses) of Switzerland?
Offer a terse response. 2.31. 